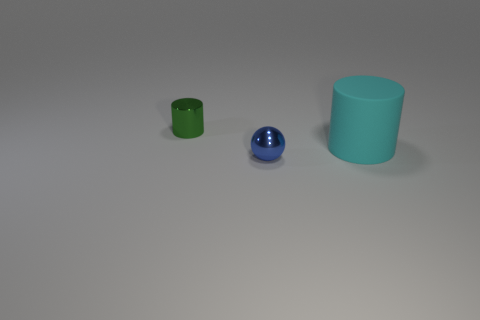Subtract all cyan cylinders. How many cylinders are left? 1 Subtract all balls. How many objects are left? 2 Subtract all red cylinders. Subtract all gray spheres. How many cylinders are left? 2 Subtract all purple spheres. How many cyan cylinders are left? 1 Subtract all green shiny cylinders. Subtract all small green objects. How many objects are left? 1 Add 1 small metallic cylinders. How many small metallic cylinders are left? 2 Add 2 green metal objects. How many green metal objects exist? 3 Add 1 cyan matte things. How many objects exist? 4 Subtract 0 gray cylinders. How many objects are left? 3 Subtract 1 spheres. How many spheres are left? 0 